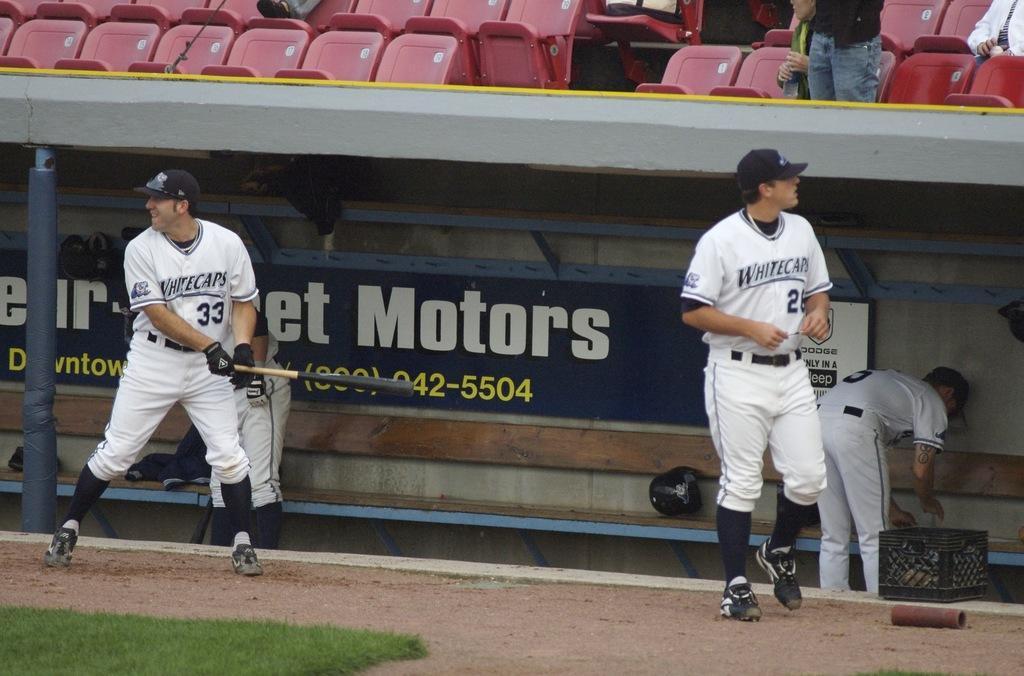Could you give a brief overview of what you see in this image? In this image I can see four persons on the ground and grass. In the background I can see a fence, boards and group of people on the seats. This image is taken during a day. 